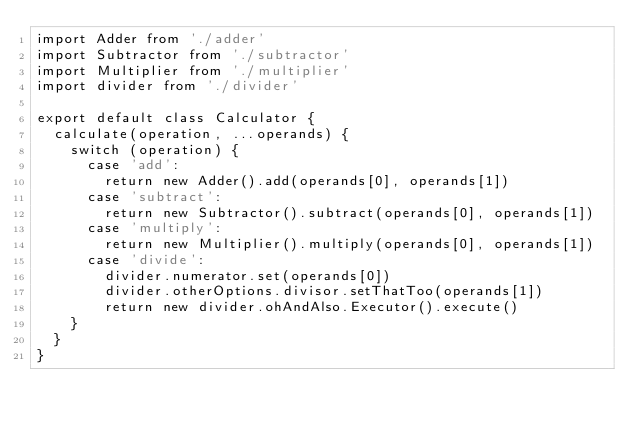Convert code to text. <code><loc_0><loc_0><loc_500><loc_500><_JavaScript_>import Adder from './adder'
import Subtractor from './subtractor'
import Multiplier from './multiplier'
import divider from './divider'

export default class Calculator {
  calculate(operation, ...operands) {
    switch (operation) {
      case 'add':
        return new Adder().add(operands[0], operands[1])
      case 'subtract':
        return new Subtractor().subtract(operands[0], operands[1])
      case 'multiply':
        return new Multiplier().multiply(operands[0], operands[1])
      case 'divide':
        divider.numerator.set(operands[0])
        divider.otherOptions.divisor.setThatToo(operands[1])
        return new divider.ohAndAlso.Executor().execute()
    }
  }
}

</code> 